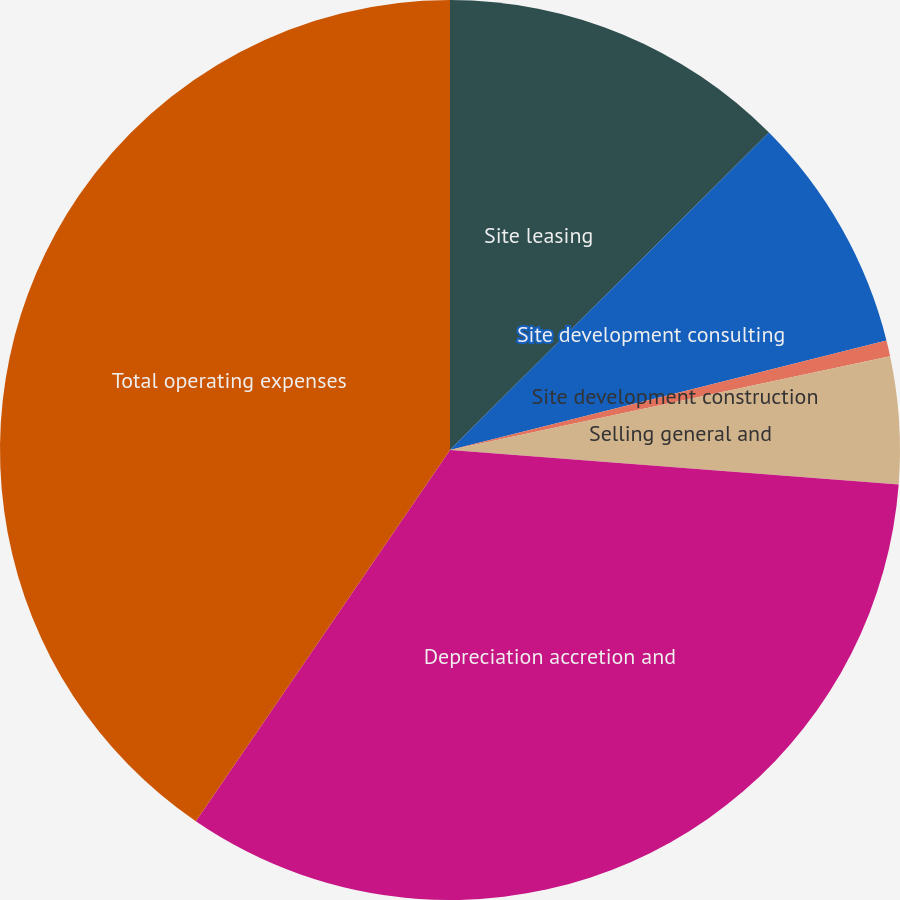Convert chart. <chart><loc_0><loc_0><loc_500><loc_500><pie_chart><fcel>Site leasing<fcel>Site development consulting<fcel>Site development construction<fcel>Selling general and<fcel>Depreciation accretion and<fcel>Total operating expenses<nl><fcel>12.54%<fcel>8.55%<fcel>0.57%<fcel>4.56%<fcel>33.34%<fcel>40.45%<nl></chart> 